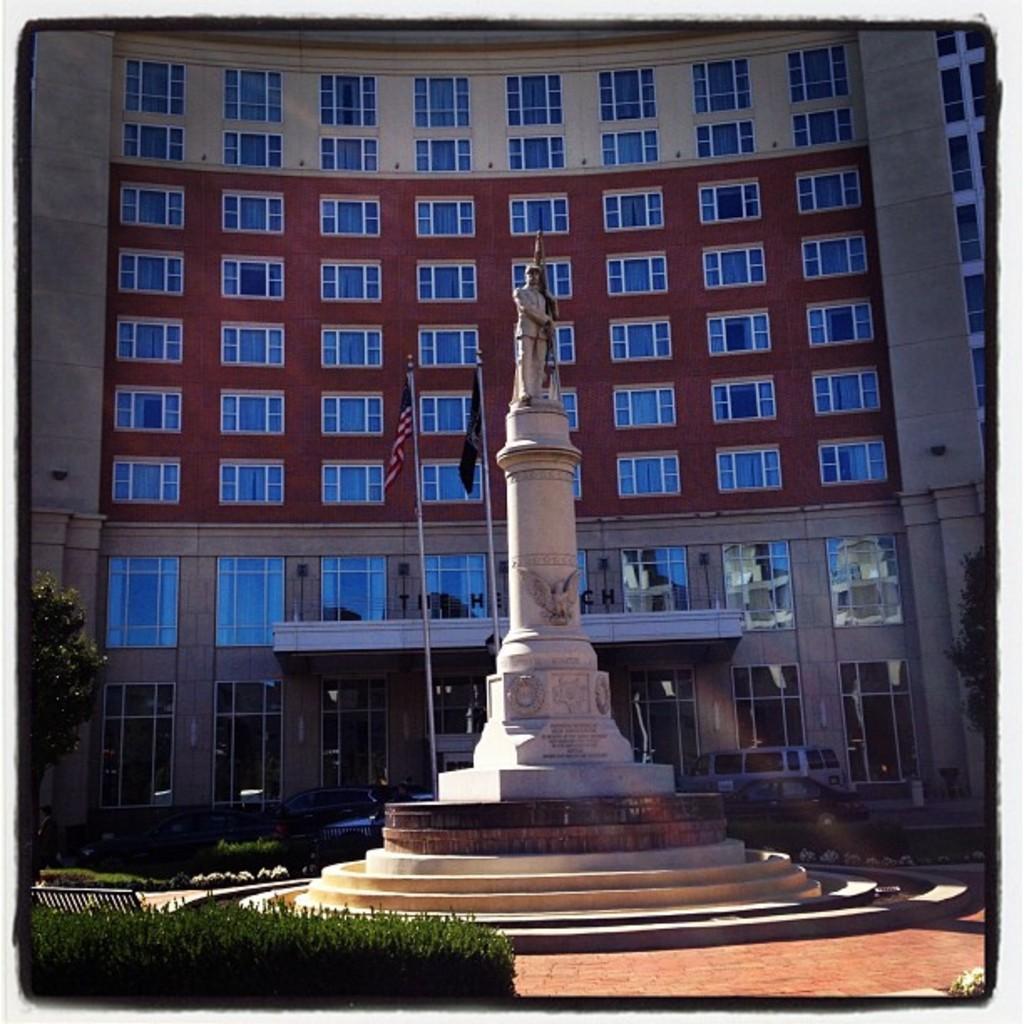Could you give a brief overview of what you see in this image? In this picture there is a statue on the stone. At the bottom i can see the plants and stairs. In the back I can see the building. In front of the door I can see the flags. On the left there is a tree near to the fencing. 